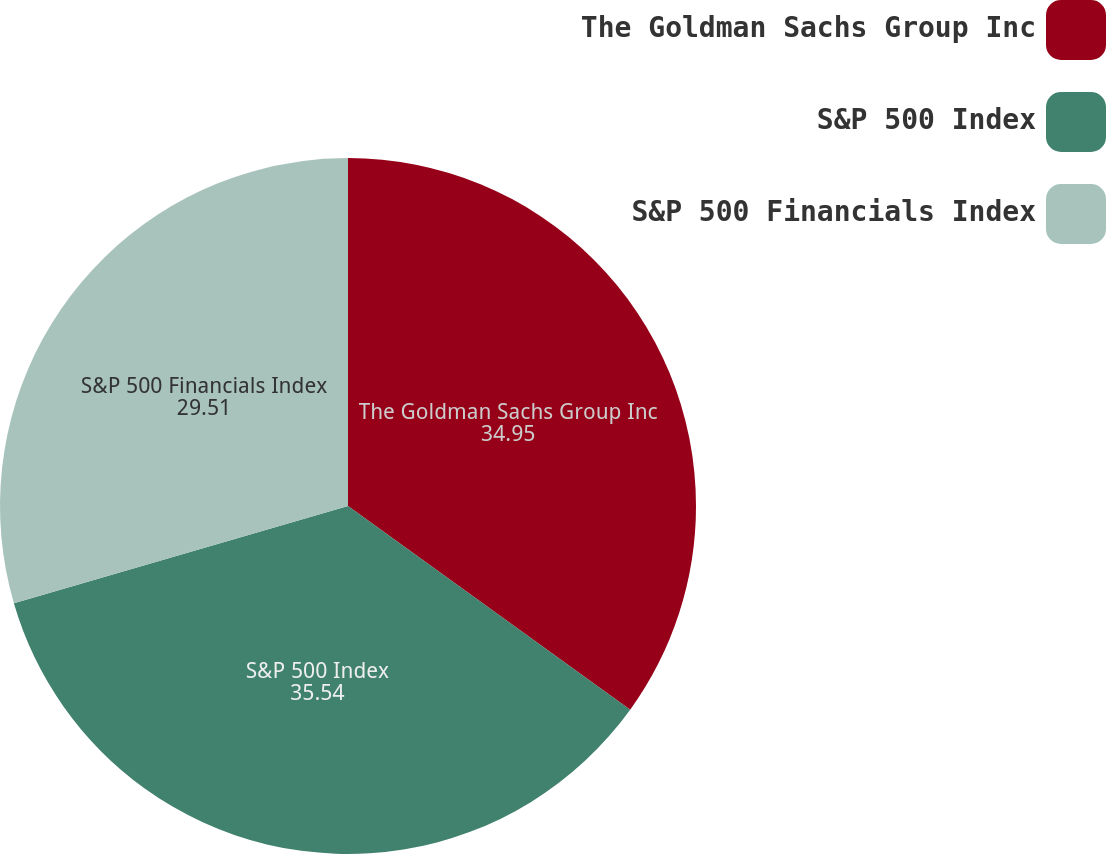Convert chart to OTSL. <chart><loc_0><loc_0><loc_500><loc_500><pie_chart><fcel>The Goldman Sachs Group Inc<fcel>S&P 500 Index<fcel>S&P 500 Financials Index<nl><fcel>34.95%<fcel>35.54%<fcel>29.51%<nl></chart> 